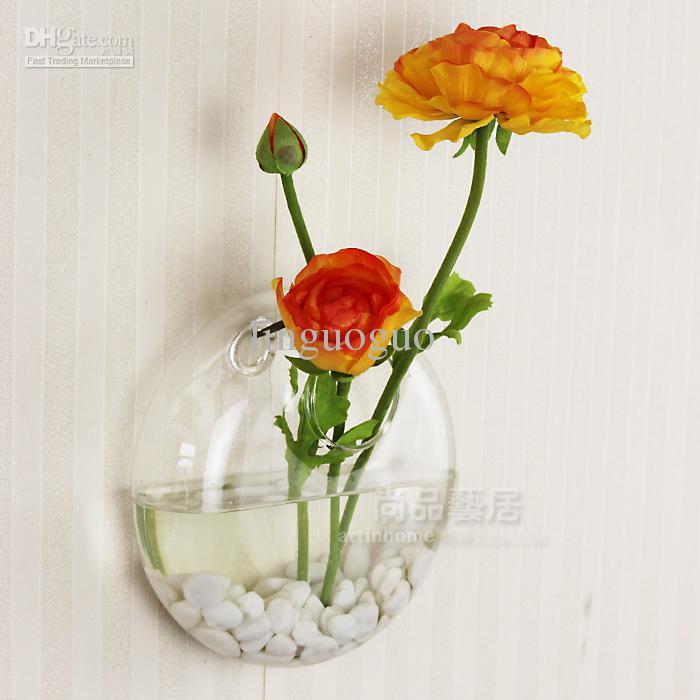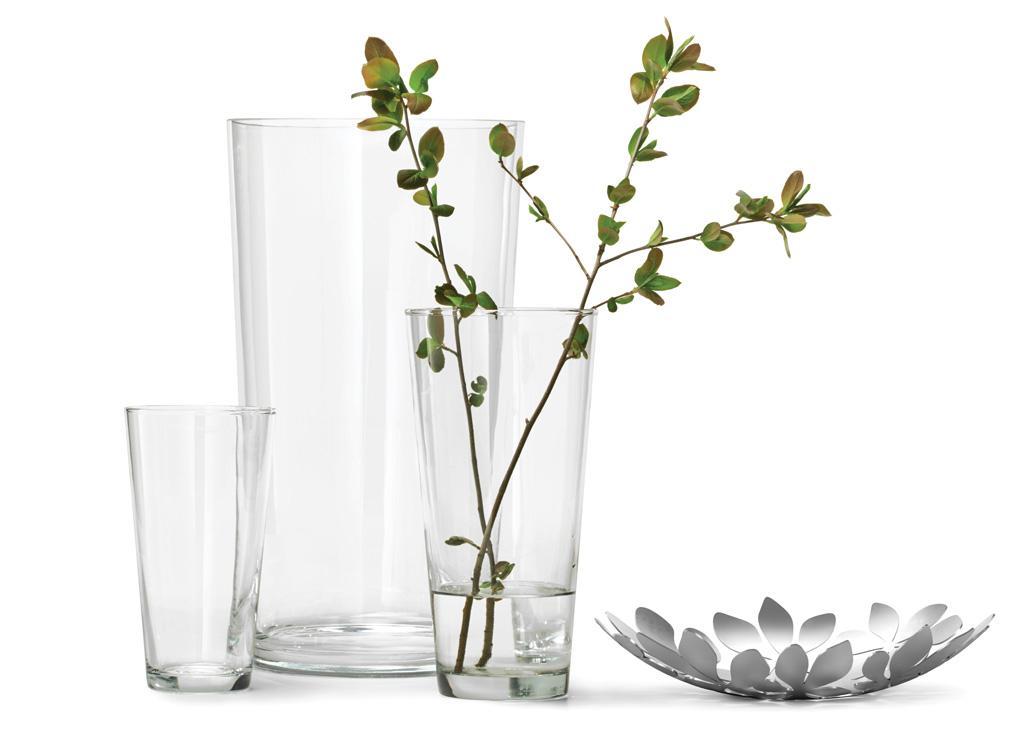The first image is the image on the left, the second image is the image on the right. For the images displayed, is the sentence "An image shows a vase containing at least one white tulip." factually correct? Answer yes or no. No. 